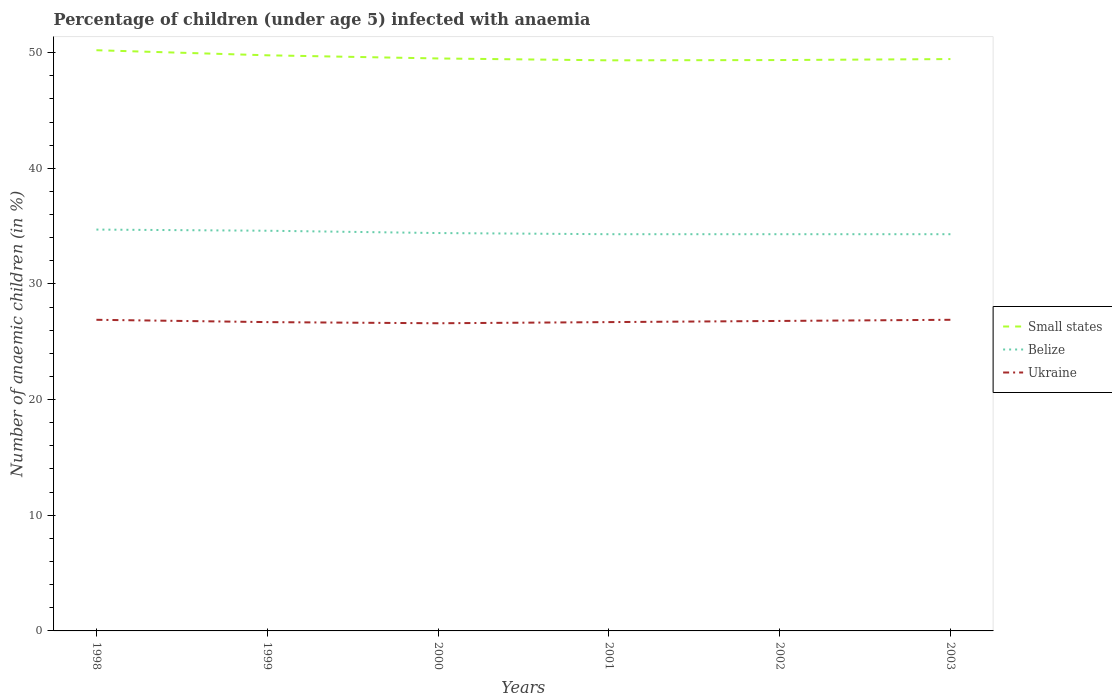Does the line corresponding to Ukraine intersect with the line corresponding to Small states?
Ensure brevity in your answer.  No. Across all years, what is the maximum percentage of children infected with anaemia in in Small states?
Your answer should be compact. 49.33. What is the total percentage of children infected with anaemia in in Ukraine in the graph?
Offer a very short reply. -0.2. What is the difference between the highest and the second highest percentage of children infected with anaemia in in Ukraine?
Make the answer very short. 0.3. What is the difference between the highest and the lowest percentage of children infected with anaemia in in Belize?
Give a very brief answer. 2. Is the percentage of children infected with anaemia in in Belize strictly greater than the percentage of children infected with anaemia in in Ukraine over the years?
Provide a succinct answer. No. What is the difference between two consecutive major ticks on the Y-axis?
Your answer should be compact. 10. Are the values on the major ticks of Y-axis written in scientific E-notation?
Your answer should be very brief. No. Does the graph contain any zero values?
Make the answer very short. No. Does the graph contain grids?
Your answer should be compact. No. What is the title of the graph?
Offer a very short reply. Percentage of children (under age 5) infected with anaemia. What is the label or title of the Y-axis?
Make the answer very short. Number of anaemic children (in %). What is the Number of anaemic children (in %) in Small states in 1998?
Offer a terse response. 50.21. What is the Number of anaemic children (in %) of Belize in 1998?
Make the answer very short. 34.7. What is the Number of anaemic children (in %) in Ukraine in 1998?
Keep it short and to the point. 26.9. What is the Number of anaemic children (in %) in Small states in 1999?
Give a very brief answer. 49.77. What is the Number of anaemic children (in %) of Belize in 1999?
Your response must be concise. 34.6. What is the Number of anaemic children (in %) of Ukraine in 1999?
Provide a succinct answer. 26.7. What is the Number of anaemic children (in %) of Small states in 2000?
Ensure brevity in your answer.  49.49. What is the Number of anaemic children (in %) of Belize in 2000?
Ensure brevity in your answer.  34.4. What is the Number of anaemic children (in %) in Ukraine in 2000?
Offer a very short reply. 26.6. What is the Number of anaemic children (in %) in Small states in 2001?
Offer a terse response. 49.33. What is the Number of anaemic children (in %) in Belize in 2001?
Your answer should be very brief. 34.3. What is the Number of anaemic children (in %) in Ukraine in 2001?
Your answer should be very brief. 26.7. What is the Number of anaemic children (in %) of Small states in 2002?
Keep it short and to the point. 49.36. What is the Number of anaemic children (in %) of Belize in 2002?
Your answer should be very brief. 34.3. What is the Number of anaemic children (in %) of Ukraine in 2002?
Keep it short and to the point. 26.8. What is the Number of anaemic children (in %) in Small states in 2003?
Provide a short and direct response. 49.44. What is the Number of anaemic children (in %) of Belize in 2003?
Your answer should be very brief. 34.3. What is the Number of anaemic children (in %) of Ukraine in 2003?
Your response must be concise. 26.9. Across all years, what is the maximum Number of anaemic children (in %) in Small states?
Ensure brevity in your answer.  50.21. Across all years, what is the maximum Number of anaemic children (in %) in Belize?
Keep it short and to the point. 34.7. Across all years, what is the maximum Number of anaemic children (in %) of Ukraine?
Your answer should be compact. 26.9. Across all years, what is the minimum Number of anaemic children (in %) in Small states?
Provide a short and direct response. 49.33. Across all years, what is the minimum Number of anaemic children (in %) in Belize?
Your answer should be very brief. 34.3. Across all years, what is the minimum Number of anaemic children (in %) of Ukraine?
Ensure brevity in your answer.  26.6. What is the total Number of anaemic children (in %) of Small states in the graph?
Offer a very short reply. 297.6. What is the total Number of anaemic children (in %) of Belize in the graph?
Make the answer very short. 206.6. What is the total Number of anaemic children (in %) of Ukraine in the graph?
Keep it short and to the point. 160.6. What is the difference between the Number of anaemic children (in %) of Small states in 1998 and that in 1999?
Provide a succinct answer. 0.44. What is the difference between the Number of anaemic children (in %) of Ukraine in 1998 and that in 1999?
Provide a succinct answer. 0.2. What is the difference between the Number of anaemic children (in %) in Small states in 1998 and that in 2000?
Your answer should be very brief. 0.71. What is the difference between the Number of anaemic children (in %) of Belize in 1998 and that in 2000?
Provide a short and direct response. 0.3. What is the difference between the Number of anaemic children (in %) in Small states in 1998 and that in 2001?
Your answer should be compact. 0.87. What is the difference between the Number of anaemic children (in %) in Belize in 1998 and that in 2001?
Your answer should be very brief. 0.4. What is the difference between the Number of anaemic children (in %) of Small states in 1998 and that in 2002?
Give a very brief answer. 0.85. What is the difference between the Number of anaemic children (in %) in Belize in 1998 and that in 2002?
Your answer should be compact. 0.4. What is the difference between the Number of anaemic children (in %) of Small states in 1998 and that in 2003?
Offer a very short reply. 0.76. What is the difference between the Number of anaemic children (in %) of Belize in 1998 and that in 2003?
Your answer should be compact. 0.4. What is the difference between the Number of anaemic children (in %) in Ukraine in 1998 and that in 2003?
Make the answer very short. 0. What is the difference between the Number of anaemic children (in %) in Small states in 1999 and that in 2000?
Make the answer very short. 0.27. What is the difference between the Number of anaemic children (in %) in Belize in 1999 and that in 2000?
Offer a very short reply. 0.2. What is the difference between the Number of anaemic children (in %) of Small states in 1999 and that in 2001?
Your answer should be compact. 0.44. What is the difference between the Number of anaemic children (in %) of Ukraine in 1999 and that in 2001?
Provide a succinct answer. 0. What is the difference between the Number of anaemic children (in %) of Small states in 1999 and that in 2002?
Ensure brevity in your answer.  0.41. What is the difference between the Number of anaemic children (in %) of Small states in 1999 and that in 2003?
Give a very brief answer. 0.33. What is the difference between the Number of anaemic children (in %) of Belize in 1999 and that in 2003?
Your answer should be very brief. 0.3. What is the difference between the Number of anaemic children (in %) of Small states in 2000 and that in 2001?
Your response must be concise. 0.16. What is the difference between the Number of anaemic children (in %) in Belize in 2000 and that in 2001?
Ensure brevity in your answer.  0.1. What is the difference between the Number of anaemic children (in %) of Small states in 2000 and that in 2002?
Ensure brevity in your answer.  0.14. What is the difference between the Number of anaemic children (in %) of Small states in 2000 and that in 2003?
Give a very brief answer. 0.05. What is the difference between the Number of anaemic children (in %) of Ukraine in 2000 and that in 2003?
Provide a succinct answer. -0.3. What is the difference between the Number of anaemic children (in %) of Small states in 2001 and that in 2002?
Make the answer very short. -0.02. What is the difference between the Number of anaemic children (in %) in Small states in 2001 and that in 2003?
Make the answer very short. -0.11. What is the difference between the Number of anaemic children (in %) of Ukraine in 2001 and that in 2003?
Give a very brief answer. -0.2. What is the difference between the Number of anaemic children (in %) in Small states in 2002 and that in 2003?
Your answer should be compact. -0.09. What is the difference between the Number of anaemic children (in %) of Belize in 2002 and that in 2003?
Provide a short and direct response. 0. What is the difference between the Number of anaemic children (in %) in Small states in 1998 and the Number of anaemic children (in %) in Belize in 1999?
Give a very brief answer. 15.61. What is the difference between the Number of anaemic children (in %) of Small states in 1998 and the Number of anaemic children (in %) of Ukraine in 1999?
Your response must be concise. 23.51. What is the difference between the Number of anaemic children (in %) of Small states in 1998 and the Number of anaemic children (in %) of Belize in 2000?
Offer a very short reply. 15.81. What is the difference between the Number of anaemic children (in %) of Small states in 1998 and the Number of anaemic children (in %) of Ukraine in 2000?
Your answer should be very brief. 23.61. What is the difference between the Number of anaemic children (in %) in Small states in 1998 and the Number of anaemic children (in %) in Belize in 2001?
Your answer should be very brief. 15.91. What is the difference between the Number of anaemic children (in %) in Small states in 1998 and the Number of anaemic children (in %) in Ukraine in 2001?
Offer a very short reply. 23.51. What is the difference between the Number of anaemic children (in %) in Belize in 1998 and the Number of anaemic children (in %) in Ukraine in 2001?
Your answer should be compact. 8. What is the difference between the Number of anaemic children (in %) in Small states in 1998 and the Number of anaemic children (in %) in Belize in 2002?
Give a very brief answer. 15.91. What is the difference between the Number of anaemic children (in %) in Small states in 1998 and the Number of anaemic children (in %) in Ukraine in 2002?
Offer a terse response. 23.41. What is the difference between the Number of anaemic children (in %) in Small states in 1998 and the Number of anaemic children (in %) in Belize in 2003?
Ensure brevity in your answer.  15.91. What is the difference between the Number of anaemic children (in %) of Small states in 1998 and the Number of anaemic children (in %) of Ukraine in 2003?
Provide a succinct answer. 23.31. What is the difference between the Number of anaemic children (in %) of Belize in 1998 and the Number of anaemic children (in %) of Ukraine in 2003?
Give a very brief answer. 7.8. What is the difference between the Number of anaemic children (in %) of Small states in 1999 and the Number of anaemic children (in %) of Belize in 2000?
Your answer should be very brief. 15.37. What is the difference between the Number of anaemic children (in %) of Small states in 1999 and the Number of anaemic children (in %) of Ukraine in 2000?
Offer a terse response. 23.17. What is the difference between the Number of anaemic children (in %) in Small states in 1999 and the Number of anaemic children (in %) in Belize in 2001?
Your answer should be compact. 15.47. What is the difference between the Number of anaemic children (in %) in Small states in 1999 and the Number of anaemic children (in %) in Ukraine in 2001?
Your response must be concise. 23.07. What is the difference between the Number of anaemic children (in %) of Small states in 1999 and the Number of anaemic children (in %) of Belize in 2002?
Your answer should be compact. 15.47. What is the difference between the Number of anaemic children (in %) of Small states in 1999 and the Number of anaemic children (in %) of Ukraine in 2002?
Provide a succinct answer. 22.97. What is the difference between the Number of anaemic children (in %) in Small states in 1999 and the Number of anaemic children (in %) in Belize in 2003?
Offer a terse response. 15.47. What is the difference between the Number of anaemic children (in %) of Small states in 1999 and the Number of anaemic children (in %) of Ukraine in 2003?
Give a very brief answer. 22.87. What is the difference between the Number of anaemic children (in %) in Small states in 2000 and the Number of anaemic children (in %) in Belize in 2001?
Your response must be concise. 15.19. What is the difference between the Number of anaemic children (in %) of Small states in 2000 and the Number of anaemic children (in %) of Ukraine in 2001?
Keep it short and to the point. 22.79. What is the difference between the Number of anaemic children (in %) of Small states in 2000 and the Number of anaemic children (in %) of Belize in 2002?
Ensure brevity in your answer.  15.19. What is the difference between the Number of anaemic children (in %) of Small states in 2000 and the Number of anaemic children (in %) of Ukraine in 2002?
Offer a terse response. 22.69. What is the difference between the Number of anaemic children (in %) of Small states in 2000 and the Number of anaemic children (in %) of Belize in 2003?
Offer a very short reply. 15.19. What is the difference between the Number of anaemic children (in %) in Small states in 2000 and the Number of anaemic children (in %) in Ukraine in 2003?
Provide a succinct answer. 22.59. What is the difference between the Number of anaemic children (in %) of Small states in 2001 and the Number of anaemic children (in %) of Belize in 2002?
Keep it short and to the point. 15.03. What is the difference between the Number of anaemic children (in %) in Small states in 2001 and the Number of anaemic children (in %) in Ukraine in 2002?
Provide a short and direct response. 22.53. What is the difference between the Number of anaemic children (in %) in Belize in 2001 and the Number of anaemic children (in %) in Ukraine in 2002?
Your response must be concise. 7.5. What is the difference between the Number of anaemic children (in %) of Small states in 2001 and the Number of anaemic children (in %) of Belize in 2003?
Your response must be concise. 15.03. What is the difference between the Number of anaemic children (in %) of Small states in 2001 and the Number of anaemic children (in %) of Ukraine in 2003?
Make the answer very short. 22.43. What is the difference between the Number of anaemic children (in %) in Small states in 2002 and the Number of anaemic children (in %) in Belize in 2003?
Make the answer very short. 15.06. What is the difference between the Number of anaemic children (in %) in Small states in 2002 and the Number of anaemic children (in %) in Ukraine in 2003?
Make the answer very short. 22.46. What is the difference between the Number of anaemic children (in %) in Belize in 2002 and the Number of anaemic children (in %) in Ukraine in 2003?
Make the answer very short. 7.4. What is the average Number of anaemic children (in %) in Small states per year?
Offer a terse response. 49.6. What is the average Number of anaemic children (in %) of Belize per year?
Give a very brief answer. 34.43. What is the average Number of anaemic children (in %) in Ukraine per year?
Give a very brief answer. 26.77. In the year 1998, what is the difference between the Number of anaemic children (in %) of Small states and Number of anaemic children (in %) of Belize?
Your answer should be compact. 15.51. In the year 1998, what is the difference between the Number of anaemic children (in %) in Small states and Number of anaemic children (in %) in Ukraine?
Provide a succinct answer. 23.31. In the year 1998, what is the difference between the Number of anaemic children (in %) of Belize and Number of anaemic children (in %) of Ukraine?
Make the answer very short. 7.8. In the year 1999, what is the difference between the Number of anaemic children (in %) in Small states and Number of anaemic children (in %) in Belize?
Keep it short and to the point. 15.17. In the year 1999, what is the difference between the Number of anaemic children (in %) in Small states and Number of anaemic children (in %) in Ukraine?
Your response must be concise. 23.07. In the year 1999, what is the difference between the Number of anaemic children (in %) of Belize and Number of anaemic children (in %) of Ukraine?
Give a very brief answer. 7.9. In the year 2000, what is the difference between the Number of anaemic children (in %) in Small states and Number of anaemic children (in %) in Belize?
Make the answer very short. 15.09. In the year 2000, what is the difference between the Number of anaemic children (in %) of Small states and Number of anaemic children (in %) of Ukraine?
Provide a short and direct response. 22.89. In the year 2001, what is the difference between the Number of anaemic children (in %) in Small states and Number of anaemic children (in %) in Belize?
Offer a terse response. 15.03. In the year 2001, what is the difference between the Number of anaemic children (in %) in Small states and Number of anaemic children (in %) in Ukraine?
Make the answer very short. 22.63. In the year 2002, what is the difference between the Number of anaemic children (in %) of Small states and Number of anaemic children (in %) of Belize?
Make the answer very short. 15.06. In the year 2002, what is the difference between the Number of anaemic children (in %) in Small states and Number of anaemic children (in %) in Ukraine?
Your response must be concise. 22.56. In the year 2002, what is the difference between the Number of anaemic children (in %) in Belize and Number of anaemic children (in %) in Ukraine?
Make the answer very short. 7.5. In the year 2003, what is the difference between the Number of anaemic children (in %) in Small states and Number of anaemic children (in %) in Belize?
Give a very brief answer. 15.14. In the year 2003, what is the difference between the Number of anaemic children (in %) in Small states and Number of anaemic children (in %) in Ukraine?
Keep it short and to the point. 22.54. What is the ratio of the Number of anaemic children (in %) in Small states in 1998 to that in 1999?
Provide a succinct answer. 1.01. What is the ratio of the Number of anaemic children (in %) of Belize in 1998 to that in 1999?
Offer a very short reply. 1. What is the ratio of the Number of anaemic children (in %) of Ukraine in 1998 to that in 1999?
Make the answer very short. 1.01. What is the ratio of the Number of anaemic children (in %) of Small states in 1998 to that in 2000?
Keep it short and to the point. 1.01. What is the ratio of the Number of anaemic children (in %) of Belize in 1998 to that in 2000?
Offer a terse response. 1.01. What is the ratio of the Number of anaemic children (in %) in Ukraine in 1998 to that in 2000?
Make the answer very short. 1.01. What is the ratio of the Number of anaemic children (in %) of Small states in 1998 to that in 2001?
Provide a short and direct response. 1.02. What is the ratio of the Number of anaemic children (in %) of Belize in 1998 to that in 2001?
Offer a terse response. 1.01. What is the ratio of the Number of anaemic children (in %) in Ukraine in 1998 to that in 2001?
Make the answer very short. 1.01. What is the ratio of the Number of anaemic children (in %) of Small states in 1998 to that in 2002?
Offer a very short reply. 1.02. What is the ratio of the Number of anaemic children (in %) in Belize in 1998 to that in 2002?
Provide a short and direct response. 1.01. What is the ratio of the Number of anaemic children (in %) of Small states in 1998 to that in 2003?
Provide a succinct answer. 1.02. What is the ratio of the Number of anaemic children (in %) of Belize in 1998 to that in 2003?
Offer a very short reply. 1.01. What is the ratio of the Number of anaemic children (in %) of Small states in 1999 to that in 2000?
Ensure brevity in your answer.  1.01. What is the ratio of the Number of anaemic children (in %) of Belize in 1999 to that in 2000?
Your answer should be compact. 1.01. What is the ratio of the Number of anaemic children (in %) in Small states in 1999 to that in 2001?
Ensure brevity in your answer.  1.01. What is the ratio of the Number of anaemic children (in %) of Belize in 1999 to that in 2001?
Your answer should be compact. 1.01. What is the ratio of the Number of anaemic children (in %) in Ukraine in 1999 to that in 2001?
Your response must be concise. 1. What is the ratio of the Number of anaemic children (in %) in Small states in 1999 to that in 2002?
Ensure brevity in your answer.  1.01. What is the ratio of the Number of anaemic children (in %) in Belize in 1999 to that in 2002?
Your response must be concise. 1.01. What is the ratio of the Number of anaemic children (in %) of Small states in 1999 to that in 2003?
Keep it short and to the point. 1.01. What is the ratio of the Number of anaemic children (in %) of Belize in 1999 to that in 2003?
Provide a short and direct response. 1.01. What is the ratio of the Number of anaemic children (in %) of Small states in 2000 to that in 2001?
Your answer should be very brief. 1. What is the ratio of the Number of anaemic children (in %) in Belize in 2000 to that in 2001?
Your response must be concise. 1. What is the ratio of the Number of anaemic children (in %) of Belize in 2000 to that in 2002?
Offer a very short reply. 1. What is the ratio of the Number of anaemic children (in %) of Small states in 2000 to that in 2003?
Offer a very short reply. 1. What is the ratio of the Number of anaemic children (in %) in Ukraine in 2000 to that in 2003?
Your answer should be very brief. 0.99. What is the ratio of the Number of anaemic children (in %) in Small states in 2001 to that in 2002?
Ensure brevity in your answer.  1. What is the ratio of the Number of anaemic children (in %) in Belize in 2001 to that in 2002?
Give a very brief answer. 1. What is the ratio of the Number of anaemic children (in %) in Ukraine in 2001 to that in 2002?
Provide a succinct answer. 1. What is the ratio of the Number of anaemic children (in %) of Ukraine in 2001 to that in 2003?
Give a very brief answer. 0.99. What is the ratio of the Number of anaemic children (in %) of Small states in 2002 to that in 2003?
Your response must be concise. 1. What is the ratio of the Number of anaemic children (in %) in Belize in 2002 to that in 2003?
Your response must be concise. 1. What is the ratio of the Number of anaemic children (in %) of Ukraine in 2002 to that in 2003?
Offer a terse response. 1. What is the difference between the highest and the second highest Number of anaemic children (in %) in Small states?
Ensure brevity in your answer.  0.44. What is the difference between the highest and the second highest Number of anaemic children (in %) in Ukraine?
Your answer should be compact. 0. What is the difference between the highest and the lowest Number of anaemic children (in %) in Small states?
Your answer should be compact. 0.87. What is the difference between the highest and the lowest Number of anaemic children (in %) of Ukraine?
Make the answer very short. 0.3. 